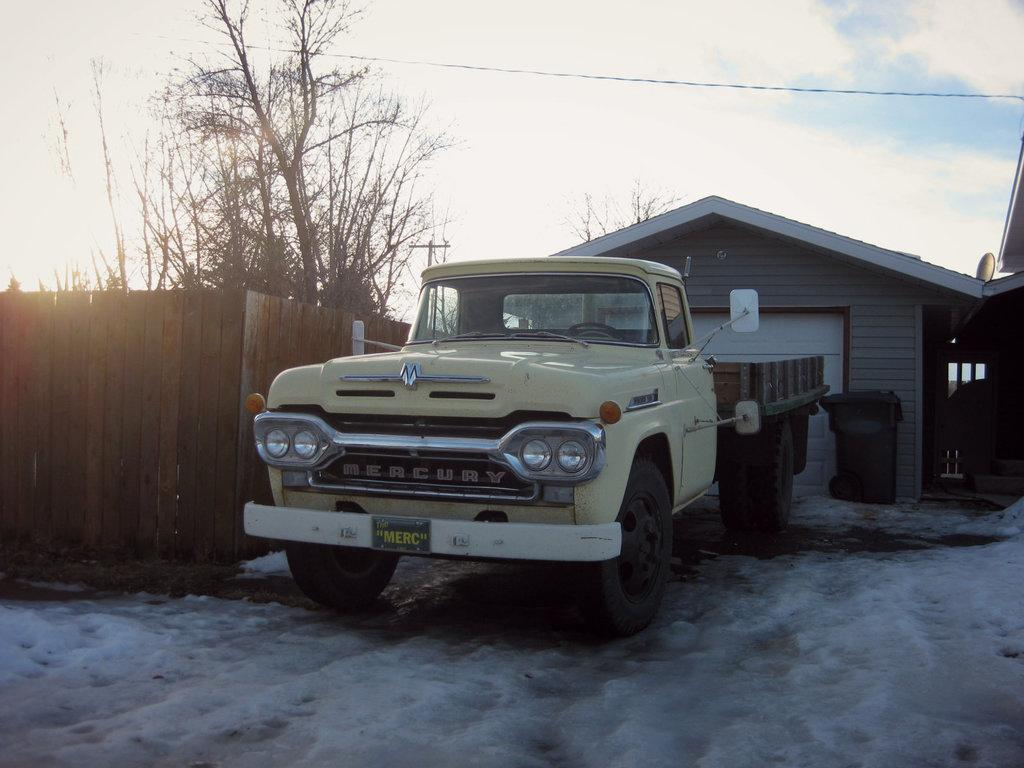Provide a one-sentence caption for the provided image. an old yellow Mercury truck is sitting in front if a garage. 